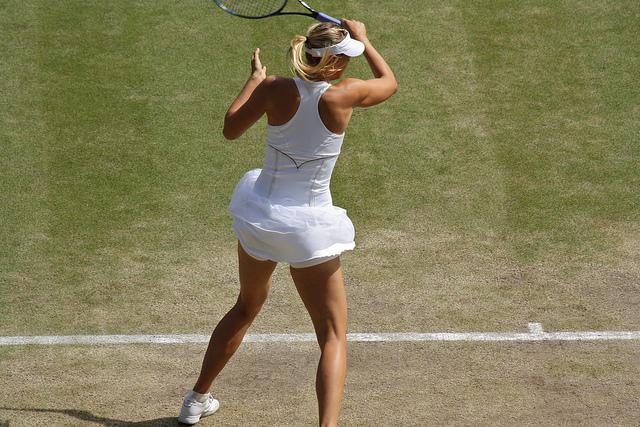How many toilets are in this bathroom?
Give a very brief answer. 0. 